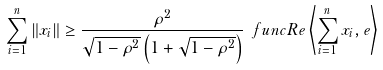Convert formula to latex. <formula><loc_0><loc_0><loc_500><loc_500>\sum _ { i = 1 } ^ { n } \left \| x _ { i } \right \| \geq \frac { \rho ^ { 2 } } { \sqrt { 1 - \rho ^ { 2 } } \left ( 1 + \sqrt { 1 - \rho ^ { 2 } } \right ) } \ f u n c { R e } \left \langle \sum _ { i = 1 } ^ { n } x _ { i } , e \right \rangle</formula> 